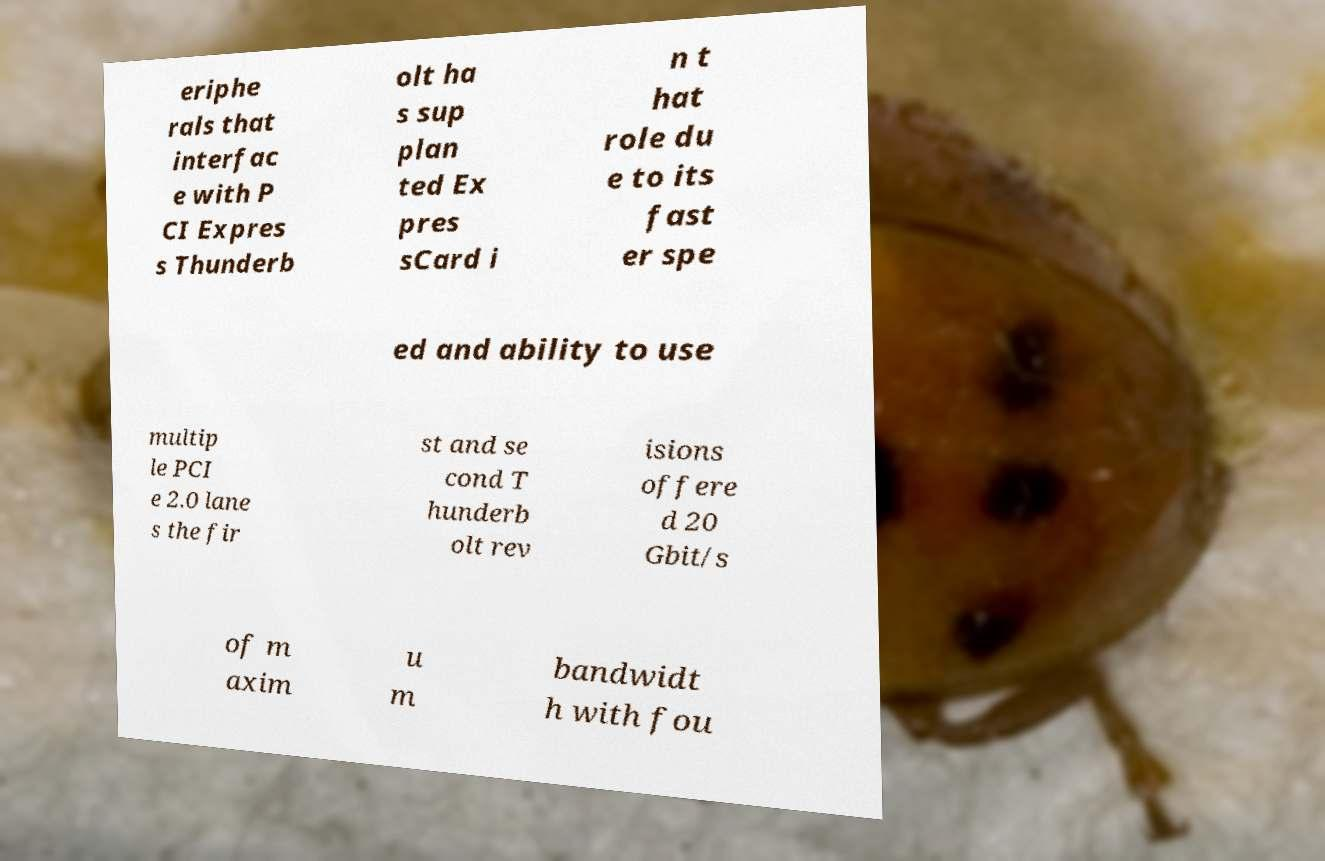What messages or text are displayed in this image? I need them in a readable, typed format. eriphe rals that interfac e with P CI Expres s Thunderb olt ha s sup plan ted Ex pres sCard i n t hat role du e to its fast er spe ed and ability to use multip le PCI e 2.0 lane s the fir st and se cond T hunderb olt rev isions offere d 20 Gbit/s of m axim u m bandwidt h with fou 